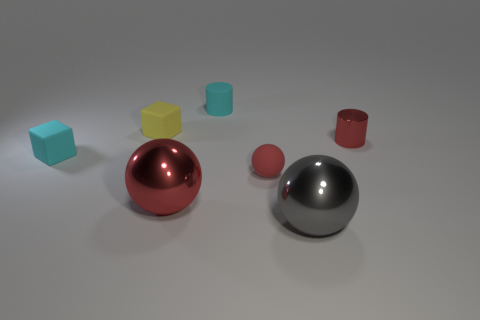Does the red cylinder have the same material as the large thing behind the gray metallic thing?
Keep it short and to the point. Yes. How many objects are red shiny things that are to the left of the gray sphere or big objects to the left of the gray metal thing?
Keep it short and to the point. 1. The small matte cylinder is what color?
Keep it short and to the point. Cyan. Is the number of red shiny spheres right of the small red ball less than the number of small green matte balls?
Your response must be concise. No. Are there any large green shiny things?
Your answer should be compact. No. Are there fewer large metal balls than small spheres?
Keep it short and to the point. No. What number of other tiny cylinders are the same material as the red cylinder?
Provide a short and direct response. 0. The small object that is the same material as the big gray thing is what color?
Offer a very short reply. Red. What is the shape of the gray thing?
Keep it short and to the point. Sphere. What number of small matte balls are the same color as the tiny metal object?
Offer a very short reply. 1. 